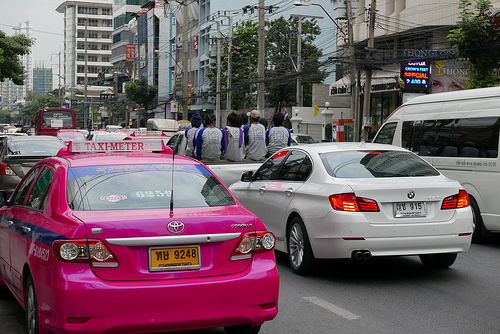<image>
Can you confirm if the taxi is to the left of the car? Yes. From this viewpoint, the taxi is positioned to the left side relative to the car. Is there a car to the left of the car? No. The car is not to the left of the car. From this viewpoint, they have a different horizontal relationship. 